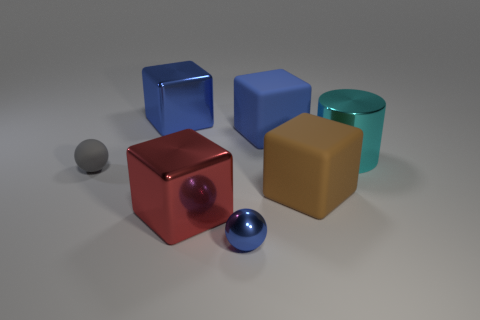There is a metal block that is the same color as the tiny metal ball; what size is it?
Provide a succinct answer. Large. The big red metal thing has what shape?
Your answer should be very brief. Cube. How many large blue blocks have the same material as the red cube?
Provide a succinct answer. 1. Is the color of the tiny metallic thing the same as the large metallic object behind the big cyan metal cylinder?
Offer a very short reply. Yes. How many metallic cubes are there?
Provide a succinct answer. 2. Is there a big rubber cube that has the same color as the small shiny thing?
Give a very brief answer. Yes. What color is the tiny ball that is behind the sphere that is in front of the ball to the left of the shiny sphere?
Give a very brief answer. Gray. Does the cyan cylinder have the same material as the cube that is on the right side of the blue rubber thing?
Give a very brief answer. No. What material is the cylinder?
Make the answer very short. Metal. How many other things are there of the same material as the brown block?
Make the answer very short. 2. 